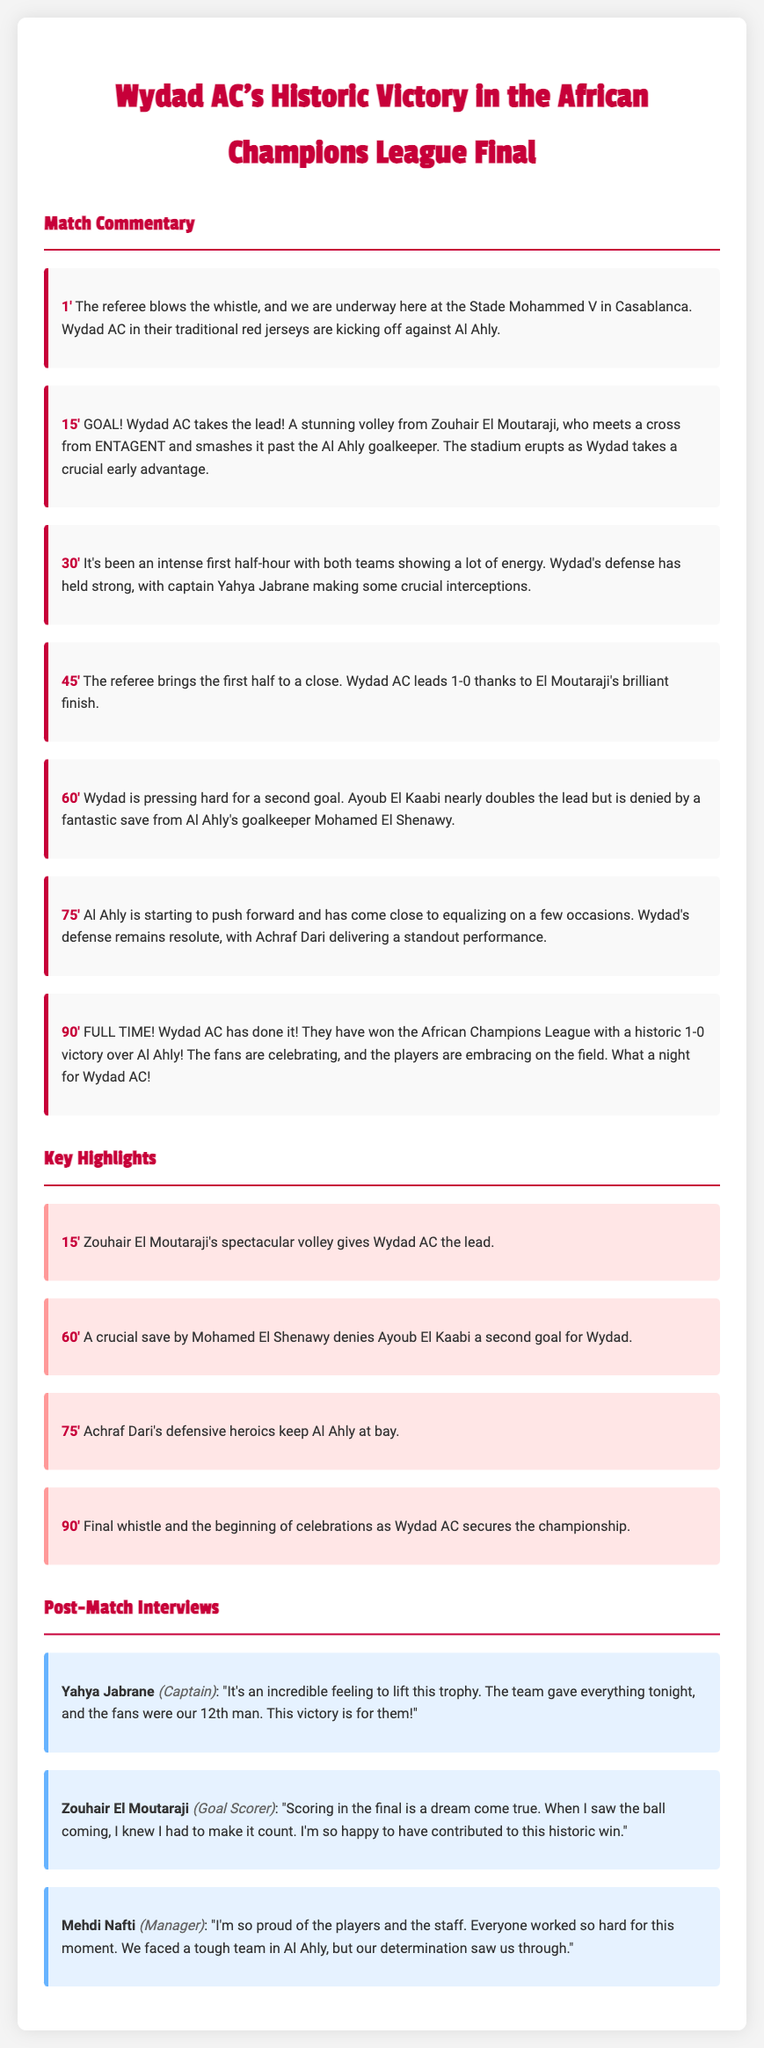what was the final score of the match? The final score of the match is mentioned at the end of the commentary. Wydad AC won by 1-0.
Answer: 1-0 who scored the goal for Wydad AC? The commentary highlights that Zouhair El Moutaraji scored the goal for Wydad AC.
Answer: Zouhair El Moutaraji at what minute did Wydad AC score their goal? The minute of the goal scored by Wydad AC is recorded in the highlights section as 15'.
Answer: 15' who made a crucial save for Al Ahly? The specific player noted for making a crucial save for Al Ahly is mentioned in the highlights.
Answer: Mohamed El Shenawy what was the position of Yahya Jabrane in Wydad AC? The role of Yahya Jabrane is stated in the post-match interview section as Captain.
Answer: Captain how many minutes did the match last? The match commentary starts at minute 1 and ends at minute 90, indicating the duration.
Answer: 90 minutes what did the fans contribute to Wydad AC according to Yahya Jabrane? Yahya Jabrane mentions in his interview that the fans were the team's 12th man.
Answer: 12th man what did Mehdi Nafti say about the team’s efforts? The manager expresses in his statement that everyone worked hard for this moment.
Answer: worked hard why was scoring in the final significant for Zouhair El Moutaraji? Zouhair El Moutaraji refers to scoring in the final as a dream come true in his interview.
Answer: dream come true 